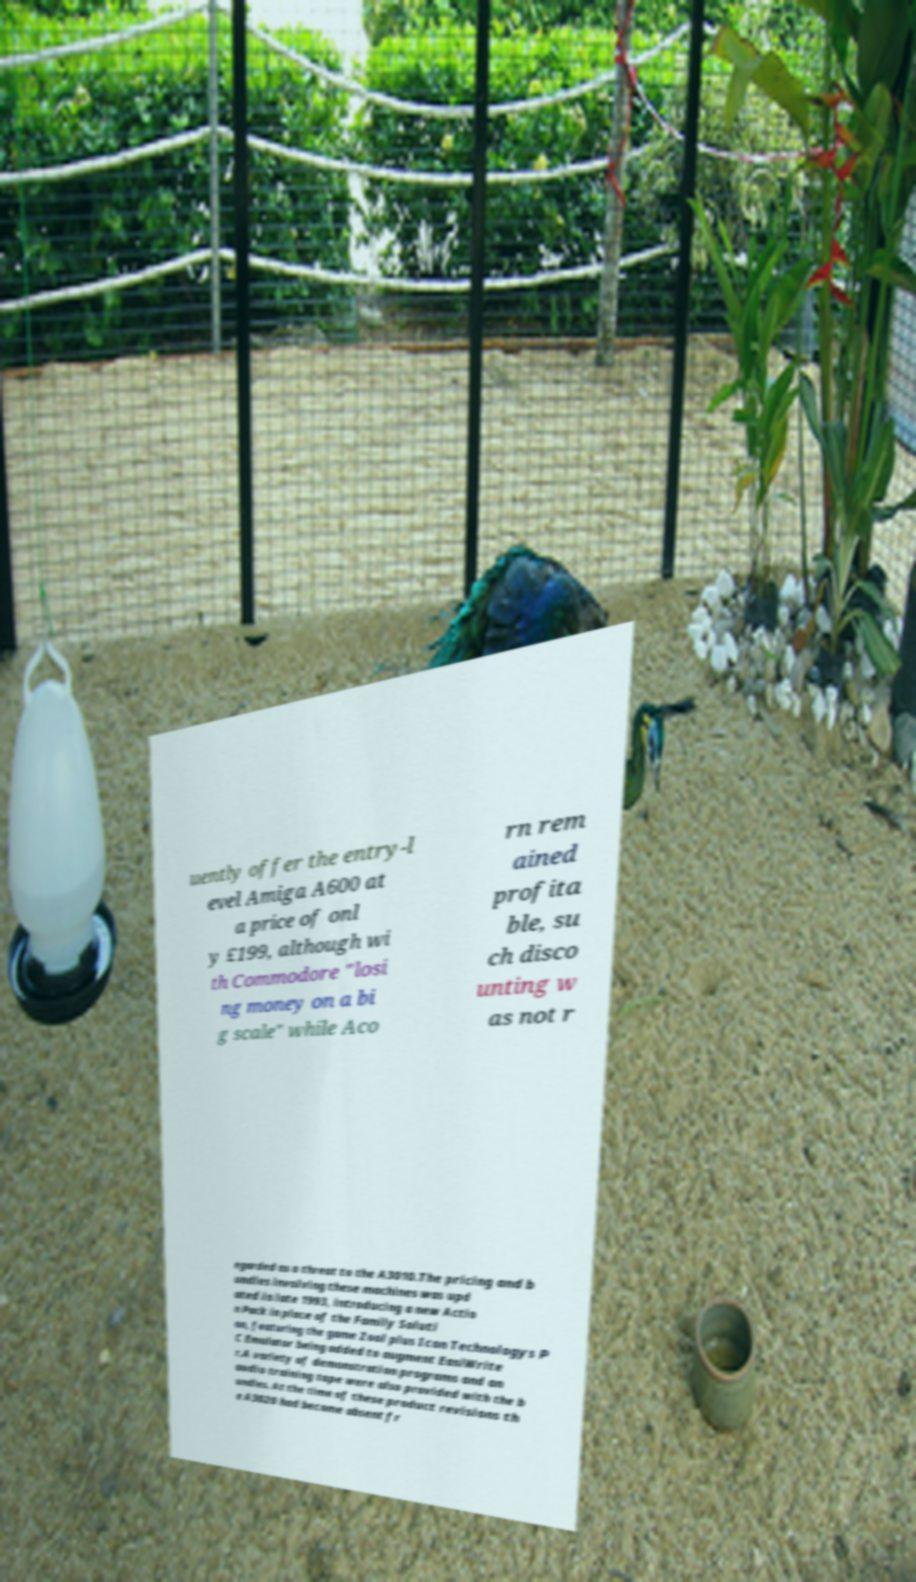Could you assist in decoding the text presented in this image and type it out clearly? uently offer the entry-l evel Amiga A600 at a price of onl y £199, although wi th Commodore "losi ng money on a bi g scale" while Aco rn rem ained profita ble, su ch disco unting w as not r egarded as a threat to the A3010.The pricing and b undles involving these machines was upd ated in late 1993, introducing a new Actio n Pack in place of the Family Soluti on, featuring the game Zool plus Icon Technologys P C Emulator being added to augment EasiWrite r.A variety of demonstration programs and an audio training tape were also provided with the b undles. At the time of these product revisions th e A3020 had become absent fr 